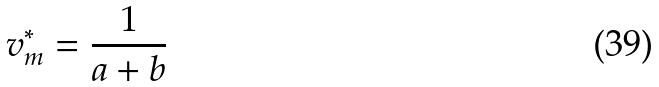Convert formula to latex. <formula><loc_0><loc_0><loc_500><loc_500>v _ { m } ^ { * } = \frac { 1 } { a + b }</formula> 